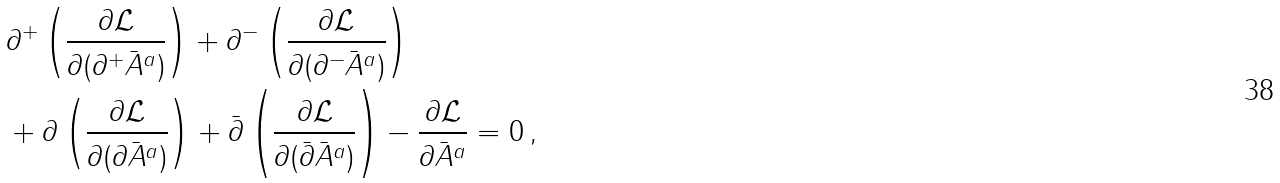<formula> <loc_0><loc_0><loc_500><loc_500>& \partial ^ { + } \left ( \frac { \partial \mathcal { L } } { \partial ( \partial ^ { + } \bar { A } ^ { a } ) } \right ) + \partial ^ { - } \left ( \frac { \partial \mathcal { L } } { \partial ( \partial ^ { - } \bar { A } ^ { a } ) } \right ) \\ & + \partial \left ( \frac { \partial \mathcal { L } } { \partial ( \partial \bar { A } ^ { a } ) } \right ) + \bar { \partial } \left ( \frac { \partial \mathcal { L } } { \partial ( \bar { \partial } \bar { A } ^ { a } ) } \right ) - \frac { \partial \mathcal { L } } { \partial \bar { A } ^ { a } } = 0 \, ,</formula> 